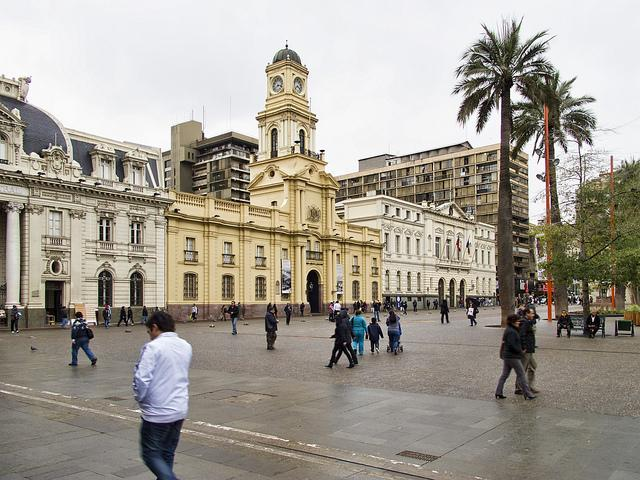What location are people strolling in?

Choices:
A) mall shops
B) race track
C) bazaar
D) plaza plaza 